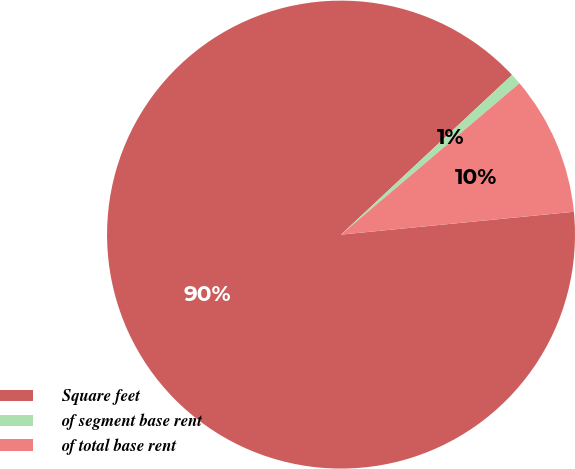<chart> <loc_0><loc_0><loc_500><loc_500><pie_chart><fcel>Square feet<fcel>of segment base rent<fcel>of total base rent<nl><fcel>89.6%<fcel>0.76%<fcel>9.64%<nl></chart> 